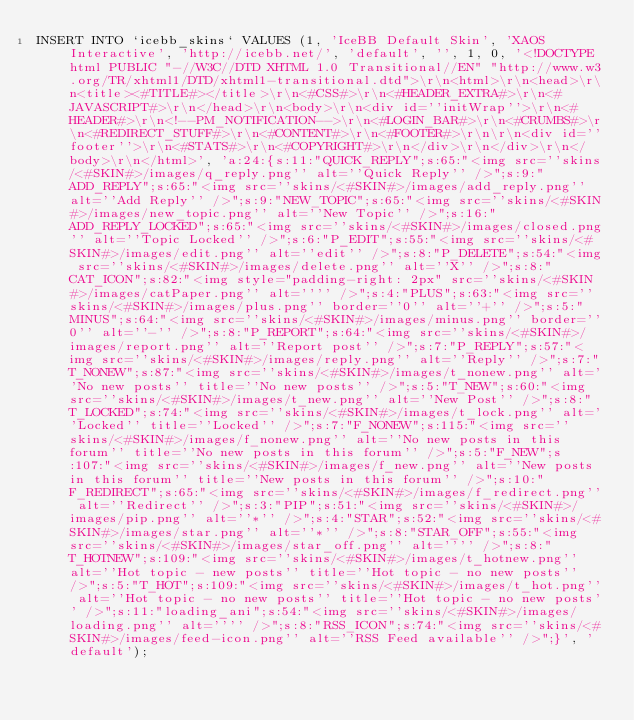<code> <loc_0><loc_0><loc_500><loc_500><_SQL_>INSERT INTO `icebb_skins` VALUES (1, 'IceBB Default Skin', 'XAOS Interactive', 'http://icebb.net/', 'default', '', 1, 0, '<!DOCTYPE html PUBLIC "-//W3C//DTD XHTML 1.0 Transitional//EN" "http://www.w3.org/TR/xhtml1/DTD/xhtml1-transitional.dtd">\r\n<html>\r\n<head>\r\n<title><#TITLE#></title>\r\n<#CSS#>\r\n<#HEADER_EXTRA#>\r\n<#JAVASCRIPT#>\r\n</head>\r\n<body>\r\n<div id=''initWrap''>\r\n<#HEADER#>\r\n<!--PM_NOTIFICATION-->\r\n<#LOGIN_BAR#>\r\n<#CRUMBS#>\r\n<#REDIRECT_STUFF#>\r\n<#CONTENT#>\r\n<#FOOTER#>\r\n\r\n<div id=''footer''>\r\n<#STATS#>\r\n<#COPYRIGHT#>\r\n</div>\r\n</div>\r\n</body>\r\n</html>', 'a:24:{s:11:"QUICK_REPLY";s:65:"<img src=''skins/<#SKIN#>/images/q_reply.png'' alt=''Quick Reply'' />";s:9:"ADD_REPLY";s:65:"<img src=''skins/<#SKIN#>/images/add_reply.png'' alt=''Add Reply'' />";s:9:"NEW_TOPIC";s:65:"<img src=''skins/<#SKIN#>/images/new_topic.png'' alt=''New Topic'' />";s:16:"ADD_REPLY_LOCKED";s:65:"<img src=''skins/<#SKIN#>/images/closed.png'' alt=''Topic Locked'' />";s:6:"P_EDIT";s:55:"<img src=''skins/<#SKIN#>/images/edit.png'' alt=''edit'' />";s:8:"P_DELETE";s:54:"<img src=''skins/<#SKIN#>/images/delete.png'' alt=''X'' />";s:8:"CAT_ICON";s:82:"<img style="padding-right: 2px" src=''skins/<#SKIN#>/images/catPaper.png'' alt='''' />";s:4:"PLUS";s:63:"<img src=''skins/<#SKIN#>/images/plus.png'' border=''0'' alt=''+'' />";s:5:"MINUS";s:64:"<img src=''skins/<#SKIN#>/images/minus.png'' border=''0'' alt=''-'' />";s:8:"P_REPORT";s:64:"<img src=''skins/<#SKIN#>/images/report.png'' alt=''Report post'' />";s:7:"P_REPLY";s:57:"<img src=''skins/<#SKIN#>/images/reply.png'' alt=''Reply'' />";s:7:"T_NONEW";s:87:"<img src=''skins/<#SKIN#>/images/t_nonew.png'' alt=''No new posts'' title=''No new posts'' />";s:5:"T_NEW";s:60:"<img src=''skins/<#SKIN#>/images/t_new.png'' alt=''New Post'' />";s:8:"T_LOCKED";s:74:"<img src=''skins/<#SKIN#>/images/t_lock.png'' alt=''Locked'' title=''Locked'' />";s:7:"F_NONEW";s:115:"<img src=''skins/<#SKIN#>/images/f_nonew.png'' alt=''No new posts in this forum'' title=''No new posts in this forum'' />";s:5:"F_NEW";s:107:"<img src=''skins/<#SKIN#>/images/f_new.png'' alt=''New posts in this forum'' title=''New posts in this forum'' />";s:10:"F_REDIRECT";s:65:"<img src=''skins/<#SKIN#>/images/f_redirect.png'' alt=''Redirect'' />";s:3:"PIP";s:51:"<img src=''skins/<#SKIN#>/images/pip.png'' alt=''*'' />";s:4:"STAR";s:52:"<img src=''skins/<#SKIN#>/images/star.png'' alt=''*'' />";s:8:"STAR_OFF";s:55:"<img src=''skins/<#SKIN#>/images/star_off.png'' alt='''' />";s:8:"T_HOTNEW";s:109:"<img src=''skins/<#SKIN#>/images/t_hotnew.png'' alt=''Hot topic - new posts'' title=''Hot topic - no new posts'' />";s:5:"T_HOT";s:109:"<img src=''skins/<#SKIN#>/images/t_hot.png'' alt=''Hot topic - no new posts'' title=''Hot topic - no new posts'' />";s:11:"loading_ani";s:54:"<img src=''skins/<#SKIN#>/images/loading.png'' alt='''' />";s:8:"RSS_ICON";s:74:"<img src=''skins/<#SKIN#>/images/feed-icon.png'' alt=''RSS Feed available'' />";}', 'default');
</code> 